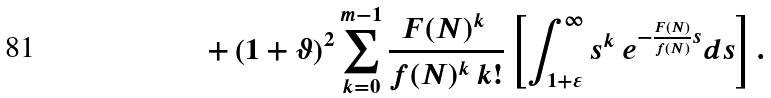Convert formula to latex. <formula><loc_0><loc_0><loc_500><loc_500>+ \left ( 1 + \vartheta \right ) ^ { 2 } \sum _ { k = 0 } ^ { m - 1 } \frac { F ( N ) ^ { k } \, } { f ( N ) ^ { k } \, k ! } \left [ \int _ { 1 + \varepsilon } ^ { \infty } s ^ { k } \, e ^ { - \frac { F ( N ) } { f ( N ) } s } d s \right ] .</formula> 